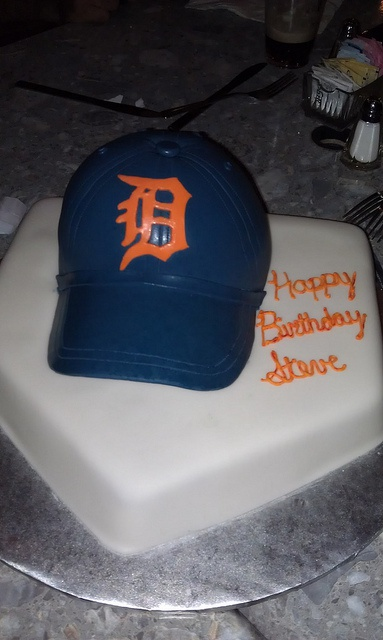Describe the objects in this image and their specific colors. I can see cake in black, darkgray, navy, and lightgray tones, cup in black tones, bottle in black and gray tones, fork in black and gray tones, and fork in black and gray tones in this image. 